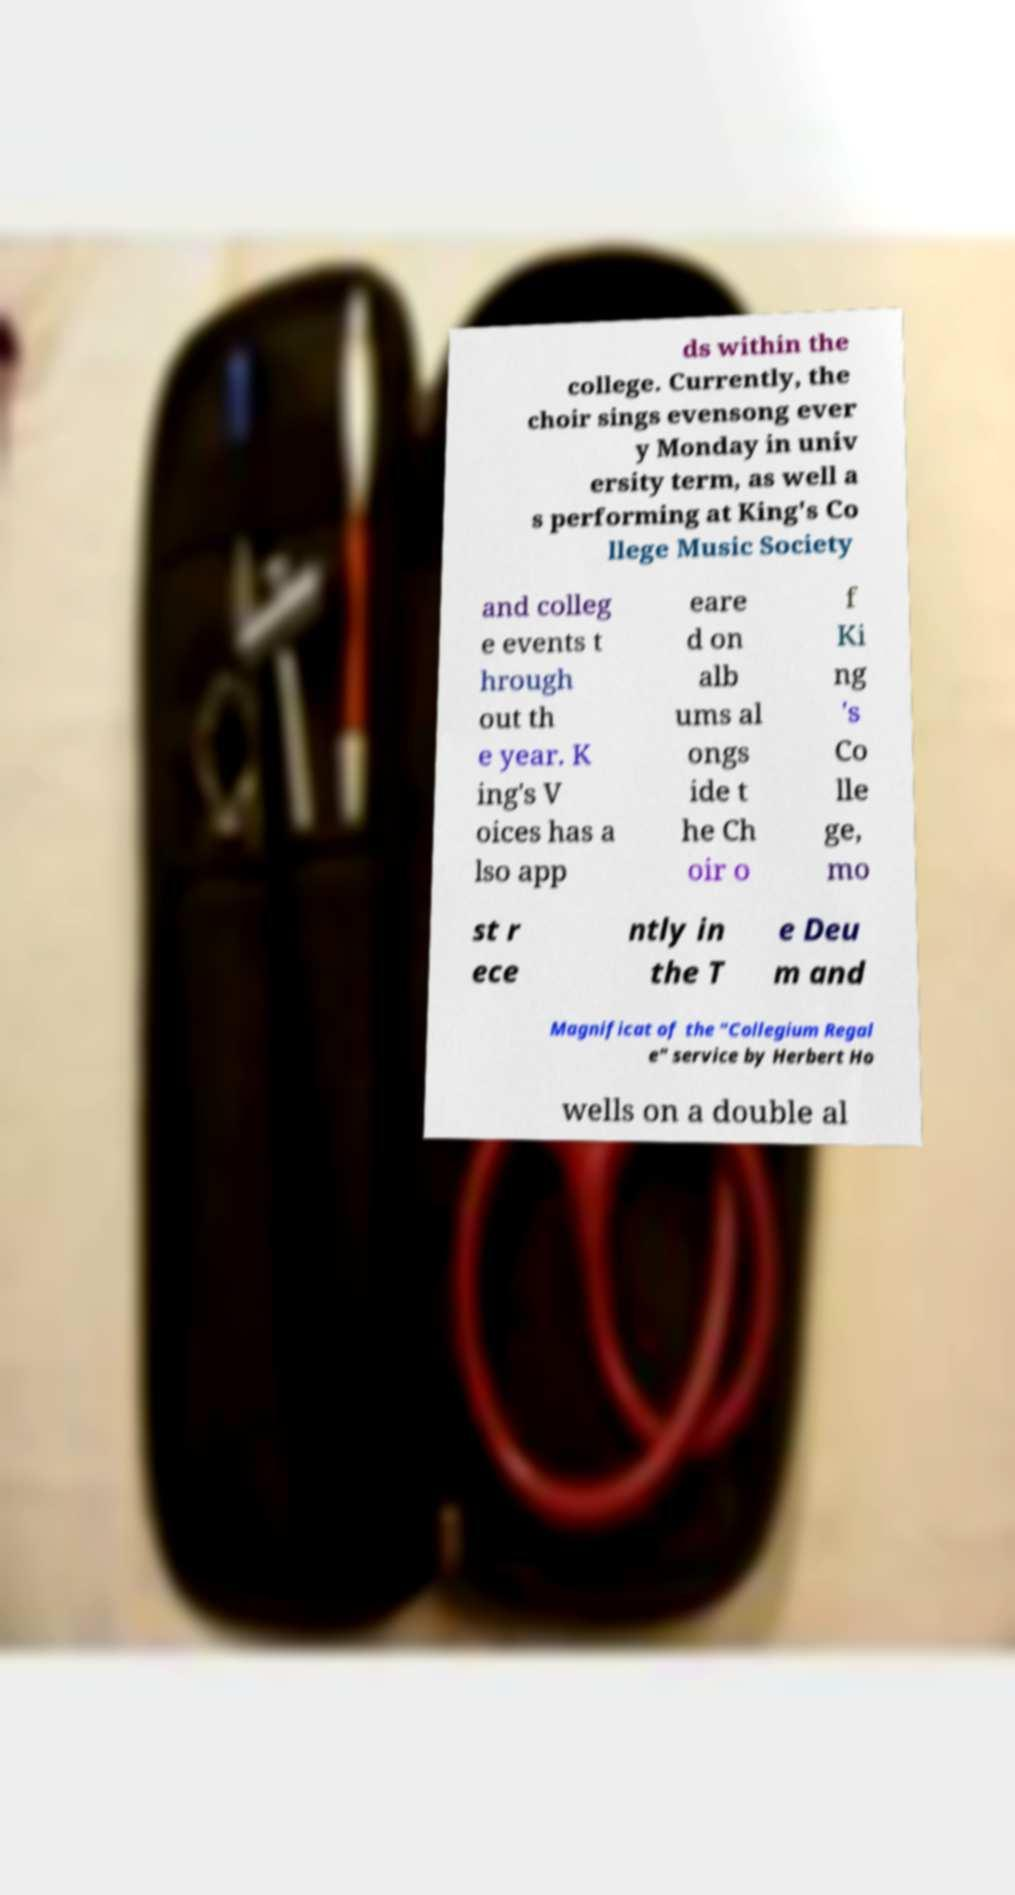I need the written content from this picture converted into text. Can you do that? ds within the college. Currently, the choir sings evensong ever y Monday in univ ersity term, as well a s performing at King's Co llege Music Society and colleg e events t hrough out th e year. K ing's V oices has a lso app eare d on alb ums al ongs ide t he Ch oir o f Ki ng 's Co lle ge, mo st r ece ntly in the T e Deu m and Magnificat of the "Collegium Regal e" service by Herbert Ho wells on a double al 